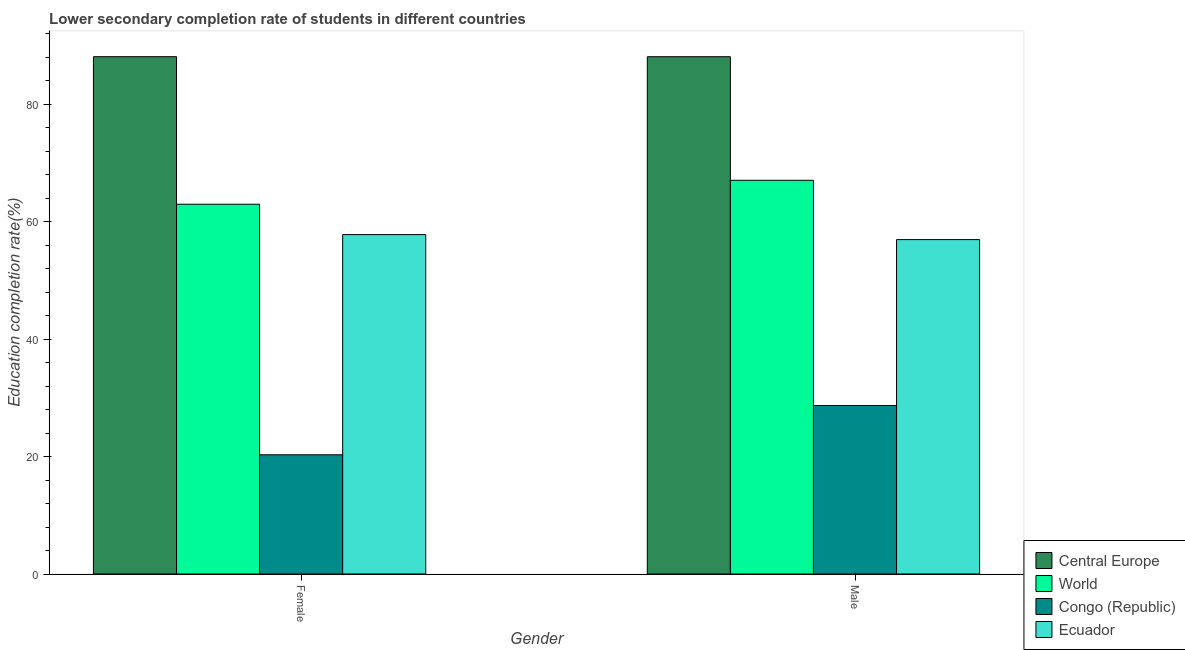How many different coloured bars are there?
Your response must be concise. 4. How many bars are there on the 2nd tick from the left?
Your response must be concise. 4. How many bars are there on the 2nd tick from the right?
Ensure brevity in your answer.  4. What is the education completion rate of male students in World?
Provide a short and direct response. 67.07. Across all countries, what is the maximum education completion rate of female students?
Your answer should be very brief. 88.12. Across all countries, what is the minimum education completion rate of male students?
Your response must be concise. 28.71. In which country was the education completion rate of female students maximum?
Make the answer very short. Central Europe. In which country was the education completion rate of male students minimum?
Give a very brief answer. Congo (Republic). What is the total education completion rate of female students in the graph?
Give a very brief answer. 229.24. What is the difference between the education completion rate of male students in World and that in Ecuador?
Keep it short and to the point. 10.11. What is the difference between the education completion rate of male students in Congo (Republic) and the education completion rate of female students in World?
Offer a terse response. -34.28. What is the average education completion rate of female students per country?
Provide a short and direct response. 57.31. What is the difference between the education completion rate of female students and education completion rate of male students in World?
Ensure brevity in your answer.  -4.08. What is the ratio of the education completion rate of male students in Ecuador to that in Congo (Republic)?
Keep it short and to the point. 1.98. In how many countries, is the education completion rate of female students greater than the average education completion rate of female students taken over all countries?
Offer a very short reply. 3. What does the 4th bar from the left in Male represents?
Your answer should be compact. Ecuador. What does the 1st bar from the right in Female represents?
Offer a very short reply. Ecuador. How many bars are there?
Make the answer very short. 8. How many countries are there in the graph?
Offer a very short reply. 4. What is the difference between two consecutive major ticks on the Y-axis?
Offer a very short reply. 20. Does the graph contain any zero values?
Offer a very short reply. No. How many legend labels are there?
Your answer should be very brief. 4. How are the legend labels stacked?
Your response must be concise. Vertical. What is the title of the graph?
Make the answer very short. Lower secondary completion rate of students in different countries. Does "Caribbean small states" appear as one of the legend labels in the graph?
Your response must be concise. No. What is the label or title of the Y-axis?
Provide a succinct answer. Education completion rate(%). What is the Education completion rate(%) of Central Europe in Female?
Give a very brief answer. 88.12. What is the Education completion rate(%) of World in Female?
Offer a very short reply. 62.99. What is the Education completion rate(%) in Congo (Republic) in Female?
Your answer should be compact. 20.31. What is the Education completion rate(%) of Ecuador in Female?
Make the answer very short. 57.82. What is the Education completion rate(%) of Central Europe in Male?
Your answer should be compact. 88.12. What is the Education completion rate(%) in World in Male?
Offer a terse response. 67.07. What is the Education completion rate(%) in Congo (Republic) in Male?
Offer a very short reply. 28.71. What is the Education completion rate(%) of Ecuador in Male?
Your answer should be very brief. 56.96. Across all Gender, what is the maximum Education completion rate(%) of Central Europe?
Your response must be concise. 88.12. Across all Gender, what is the maximum Education completion rate(%) in World?
Offer a terse response. 67.07. Across all Gender, what is the maximum Education completion rate(%) of Congo (Republic)?
Provide a short and direct response. 28.71. Across all Gender, what is the maximum Education completion rate(%) in Ecuador?
Provide a succinct answer. 57.82. Across all Gender, what is the minimum Education completion rate(%) of Central Europe?
Offer a very short reply. 88.12. Across all Gender, what is the minimum Education completion rate(%) of World?
Your response must be concise. 62.99. Across all Gender, what is the minimum Education completion rate(%) in Congo (Republic)?
Provide a succinct answer. 20.31. Across all Gender, what is the minimum Education completion rate(%) in Ecuador?
Offer a terse response. 56.96. What is the total Education completion rate(%) in Central Europe in the graph?
Offer a very short reply. 176.25. What is the total Education completion rate(%) in World in the graph?
Make the answer very short. 130.06. What is the total Education completion rate(%) in Congo (Republic) in the graph?
Keep it short and to the point. 49.02. What is the total Education completion rate(%) of Ecuador in the graph?
Make the answer very short. 114.78. What is the difference between the Education completion rate(%) in Central Europe in Female and that in Male?
Provide a short and direct response. 0. What is the difference between the Education completion rate(%) of World in Female and that in Male?
Make the answer very short. -4.08. What is the difference between the Education completion rate(%) of Congo (Republic) in Female and that in Male?
Your answer should be compact. -8.4. What is the difference between the Education completion rate(%) of Ecuador in Female and that in Male?
Offer a very short reply. 0.85. What is the difference between the Education completion rate(%) in Central Europe in Female and the Education completion rate(%) in World in Male?
Your response must be concise. 21.05. What is the difference between the Education completion rate(%) in Central Europe in Female and the Education completion rate(%) in Congo (Republic) in Male?
Provide a short and direct response. 59.42. What is the difference between the Education completion rate(%) of Central Europe in Female and the Education completion rate(%) of Ecuador in Male?
Provide a succinct answer. 31.16. What is the difference between the Education completion rate(%) in World in Female and the Education completion rate(%) in Congo (Republic) in Male?
Your answer should be very brief. 34.28. What is the difference between the Education completion rate(%) in World in Female and the Education completion rate(%) in Ecuador in Male?
Make the answer very short. 6.03. What is the difference between the Education completion rate(%) in Congo (Republic) in Female and the Education completion rate(%) in Ecuador in Male?
Provide a succinct answer. -36.66. What is the average Education completion rate(%) in Central Europe per Gender?
Keep it short and to the point. 88.12. What is the average Education completion rate(%) of World per Gender?
Provide a succinct answer. 65.03. What is the average Education completion rate(%) of Congo (Republic) per Gender?
Provide a succinct answer. 24.51. What is the average Education completion rate(%) in Ecuador per Gender?
Give a very brief answer. 57.39. What is the difference between the Education completion rate(%) in Central Europe and Education completion rate(%) in World in Female?
Your response must be concise. 25.13. What is the difference between the Education completion rate(%) in Central Europe and Education completion rate(%) in Congo (Republic) in Female?
Make the answer very short. 67.82. What is the difference between the Education completion rate(%) of Central Europe and Education completion rate(%) of Ecuador in Female?
Offer a terse response. 30.31. What is the difference between the Education completion rate(%) of World and Education completion rate(%) of Congo (Republic) in Female?
Make the answer very short. 42.68. What is the difference between the Education completion rate(%) of World and Education completion rate(%) of Ecuador in Female?
Offer a terse response. 5.18. What is the difference between the Education completion rate(%) in Congo (Republic) and Education completion rate(%) in Ecuador in Female?
Your answer should be very brief. -37.51. What is the difference between the Education completion rate(%) in Central Europe and Education completion rate(%) in World in Male?
Make the answer very short. 21.05. What is the difference between the Education completion rate(%) of Central Europe and Education completion rate(%) of Congo (Republic) in Male?
Ensure brevity in your answer.  59.41. What is the difference between the Education completion rate(%) in Central Europe and Education completion rate(%) in Ecuador in Male?
Your answer should be very brief. 31.16. What is the difference between the Education completion rate(%) of World and Education completion rate(%) of Congo (Republic) in Male?
Provide a short and direct response. 38.36. What is the difference between the Education completion rate(%) in World and Education completion rate(%) in Ecuador in Male?
Give a very brief answer. 10.11. What is the difference between the Education completion rate(%) in Congo (Republic) and Education completion rate(%) in Ecuador in Male?
Offer a terse response. -28.26. What is the ratio of the Education completion rate(%) in World in Female to that in Male?
Your response must be concise. 0.94. What is the ratio of the Education completion rate(%) of Congo (Republic) in Female to that in Male?
Offer a terse response. 0.71. What is the difference between the highest and the second highest Education completion rate(%) in Central Europe?
Your answer should be compact. 0. What is the difference between the highest and the second highest Education completion rate(%) of World?
Offer a very short reply. 4.08. What is the difference between the highest and the second highest Education completion rate(%) in Congo (Republic)?
Your answer should be very brief. 8.4. What is the difference between the highest and the second highest Education completion rate(%) of Ecuador?
Ensure brevity in your answer.  0.85. What is the difference between the highest and the lowest Education completion rate(%) in Central Europe?
Keep it short and to the point. 0. What is the difference between the highest and the lowest Education completion rate(%) of World?
Provide a succinct answer. 4.08. What is the difference between the highest and the lowest Education completion rate(%) in Congo (Republic)?
Your answer should be very brief. 8.4. What is the difference between the highest and the lowest Education completion rate(%) of Ecuador?
Offer a very short reply. 0.85. 